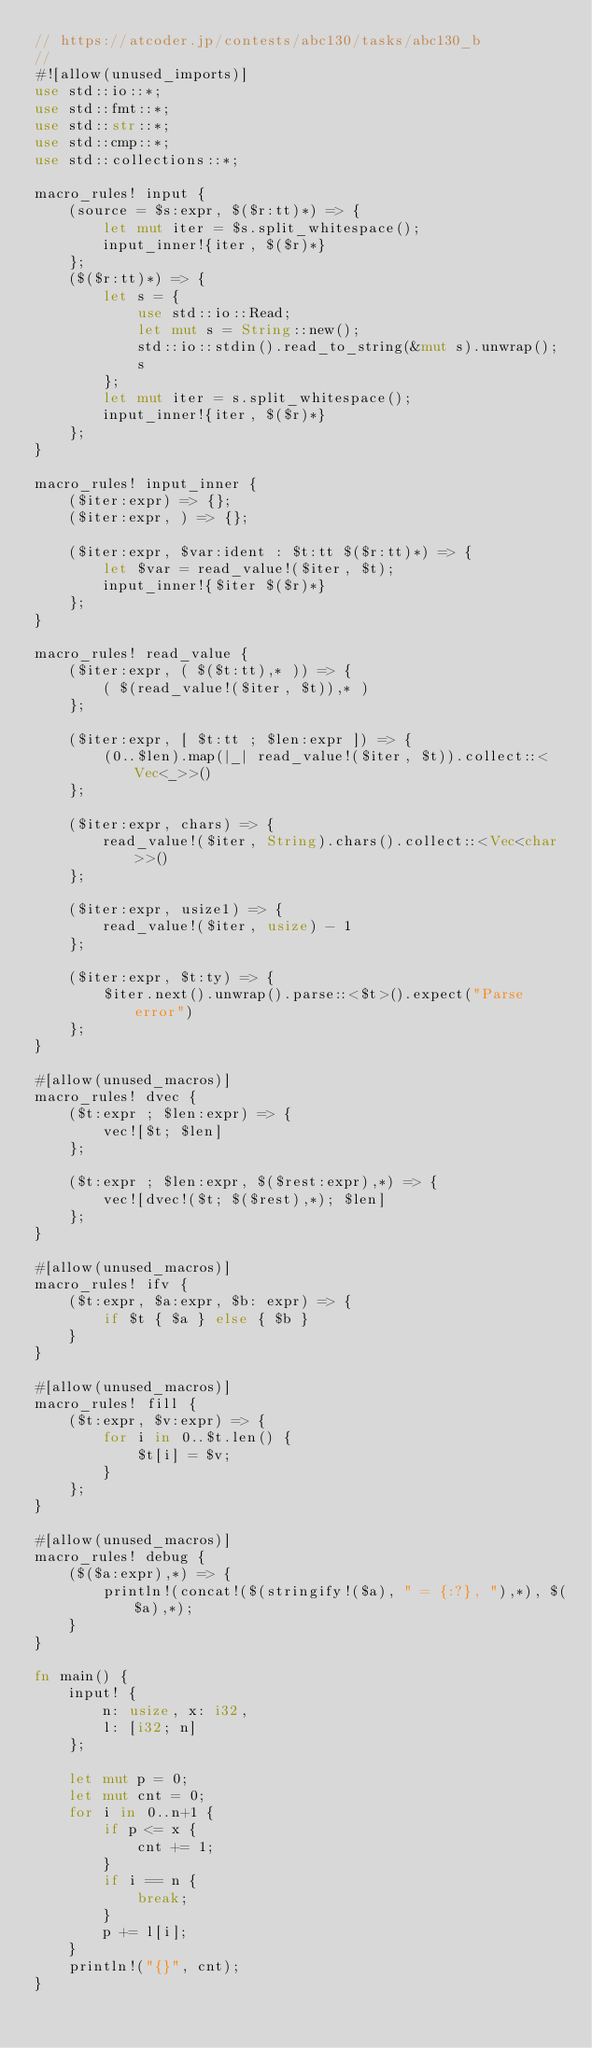<code> <loc_0><loc_0><loc_500><loc_500><_Rust_>// https://atcoder.jp/contests/abc130/tasks/abc130_b
//
#![allow(unused_imports)]
use std::io::*;
use std::fmt::*;
use std::str::*;
use std::cmp::*;
use std::collections::*;

macro_rules! input {
    (source = $s:expr, $($r:tt)*) => {
        let mut iter = $s.split_whitespace();
        input_inner!{iter, $($r)*}
    };
    ($($r:tt)*) => {
        let s = {
            use std::io::Read;
            let mut s = String::new();
            std::io::stdin().read_to_string(&mut s).unwrap();
            s
        };
        let mut iter = s.split_whitespace();
        input_inner!{iter, $($r)*}
    };
}

macro_rules! input_inner {
    ($iter:expr) => {};
    ($iter:expr, ) => {};

    ($iter:expr, $var:ident : $t:tt $($r:tt)*) => {
        let $var = read_value!($iter, $t);
        input_inner!{$iter $($r)*}
    };
}

macro_rules! read_value {
    ($iter:expr, ( $($t:tt),* )) => {
        ( $(read_value!($iter, $t)),* )
    };

    ($iter:expr, [ $t:tt ; $len:expr ]) => {
        (0..$len).map(|_| read_value!($iter, $t)).collect::<Vec<_>>()
    };

    ($iter:expr, chars) => {
        read_value!($iter, String).chars().collect::<Vec<char>>()
    };

    ($iter:expr, usize1) => {
        read_value!($iter, usize) - 1
    };

    ($iter:expr, $t:ty) => {
        $iter.next().unwrap().parse::<$t>().expect("Parse error")
    };
}

#[allow(unused_macros)]
macro_rules! dvec {
    ($t:expr ; $len:expr) => {
        vec![$t; $len]
    };

    ($t:expr ; $len:expr, $($rest:expr),*) => {
        vec![dvec!($t; $($rest),*); $len]
    };
}

#[allow(unused_macros)]
macro_rules! ifv {
    ($t:expr, $a:expr, $b: expr) => {
        if $t { $a } else { $b }
    }
}

#[allow(unused_macros)]
macro_rules! fill {
    ($t:expr, $v:expr) => {
        for i in 0..$t.len() {
            $t[i] = $v;
        }
    };
}

#[allow(unused_macros)]
macro_rules! debug {
    ($($a:expr),*) => {
        println!(concat!($(stringify!($a), " = {:?}, "),*), $($a),*);
    }
}

fn main() {
    input! {
        n: usize, x: i32,
        l: [i32; n]
    };

    let mut p = 0;
    let mut cnt = 0;
    for i in 0..n+1 {
        if p <= x {
            cnt += 1;
        }
        if i == n {
            break;
        }
        p += l[i];
    }
    println!("{}", cnt);
}
</code> 